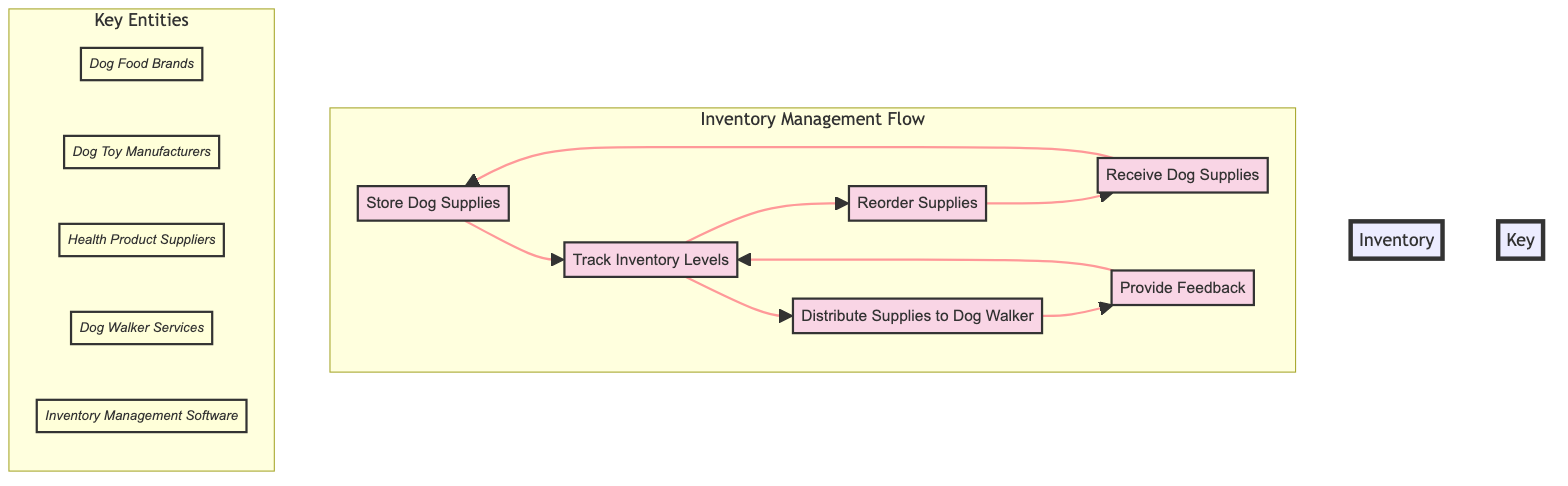What is the first process in the inventory management flow? The first process is outlined in the diagram as "Receive Dog Supplies," which indicates the starting point of the inventory management flow.
Answer: Receive Dog Supplies How many key entities are identified in the diagram? The diagram lists five distinct key entities which contribute to the inventory management process: Dog Food Brands, Dog Toy Manufacturers, Health Product Suppliers, Dog Walker Services, and Inventory Management Software.
Answer: 5 What flows from "Track Inventory Levels"? The diagram shows that "Track Inventory Levels" leads to two next processes: "Reorder Supplies" and "Distribute Supplies to Dog Walker," indicating two actions proceed from this node.
Answer: Reorder Supplies and Distribute Supplies to Dog Walker Which process follows "Provide Feedback"? According to the flowchart, after "Provide Feedback," the next process is "Track Inventory Levels," showing the cyclical nature of feedback informing inventory tracking.
Answer: Track Inventory Levels What is the purpose of the "Distribute Supplies to Dog Walker" process? The process "Distribute Supplies to Dog Walker" is designed to prepare and hand over specific supplies that the dog walker needs for their daily duties, emphasizing its role in connecting with service providers.
Answer: To prepare and hand over specific supplies needed by the dog walker for daily use What is the relationship between "Reorder Supplies" and "Receive Dog Supplies"? The flowchart illustrates that "Reorder Supplies" leads back to "Receive Dog Supplies," indicating a cycle where reordering directly aligns with the receipt of new supplies from suppliers.
Answer: They are connected in a cycle 